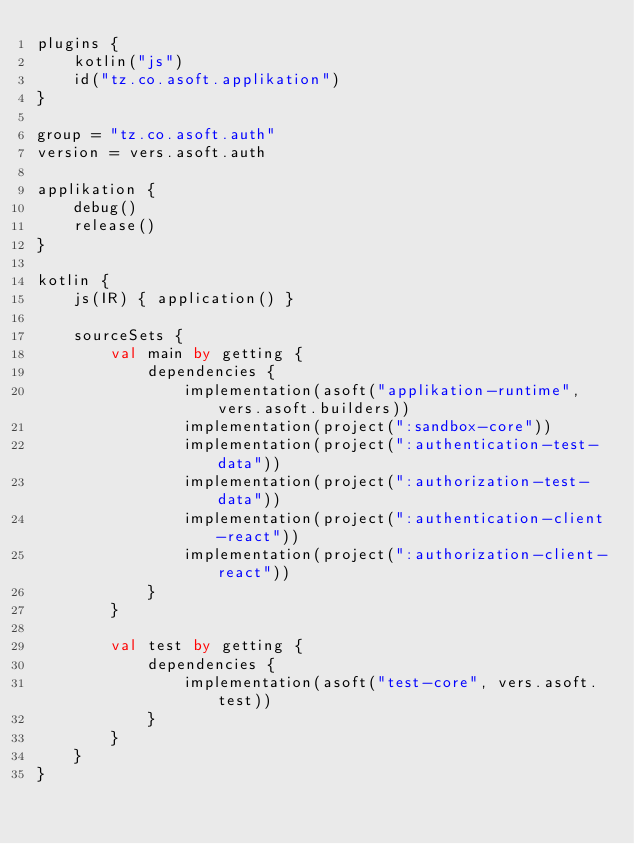Convert code to text. <code><loc_0><loc_0><loc_500><loc_500><_Kotlin_>plugins {
    kotlin("js")
    id("tz.co.asoft.applikation")
}

group = "tz.co.asoft.auth"
version = vers.asoft.auth

applikation {
    debug()
    release()
}

kotlin {
    js(IR) { application() }

    sourceSets {
        val main by getting {
            dependencies {
                implementation(asoft("applikation-runtime", vers.asoft.builders))
                implementation(project(":sandbox-core"))
                implementation(project(":authentication-test-data"))
                implementation(project(":authorization-test-data"))
                implementation(project(":authentication-client-react"))
                implementation(project(":authorization-client-react"))
            }
        }

        val test by getting {
            dependencies {
                implementation(asoft("test-core", vers.asoft.test))
            }
        }
    }
}
</code> 